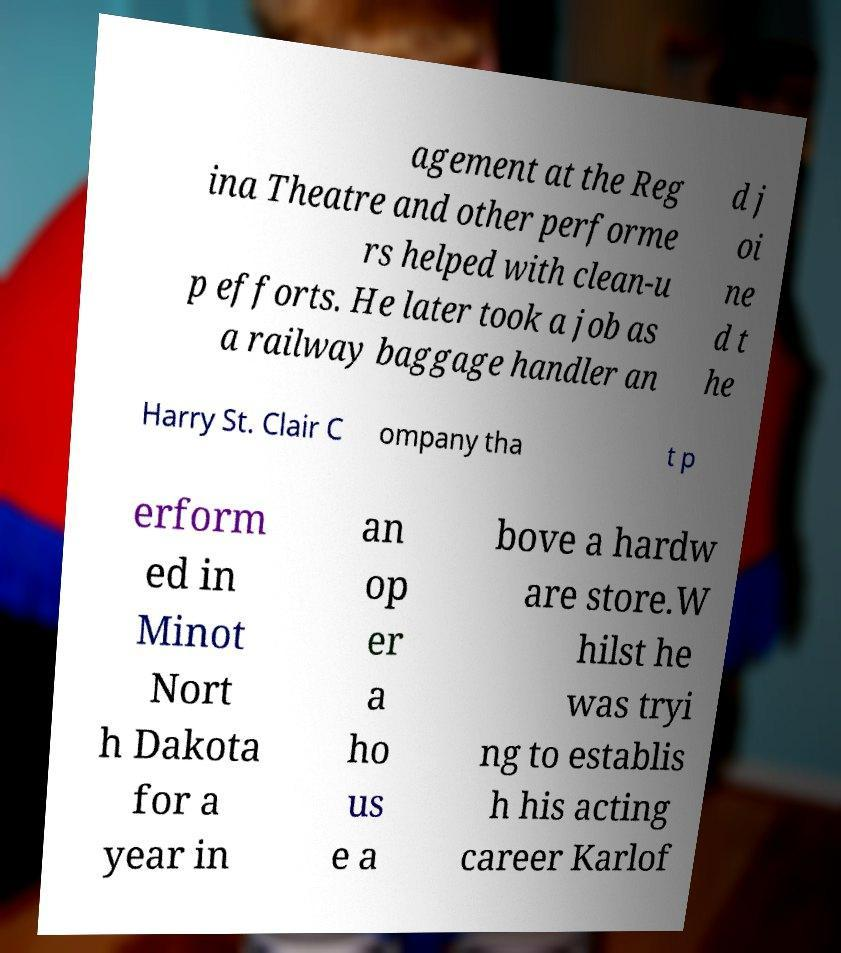Could you extract and type out the text from this image? agement at the Reg ina Theatre and other performe rs helped with clean-u p efforts. He later took a job as a railway baggage handler an d j oi ne d t he Harry St. Clair C ompany tha t p erform ed in Minot Nort h Dakota for a year in an op er a ho us e a bove a hardw are store.W hilst he was tryi ng to establis h his acting career Karlof 